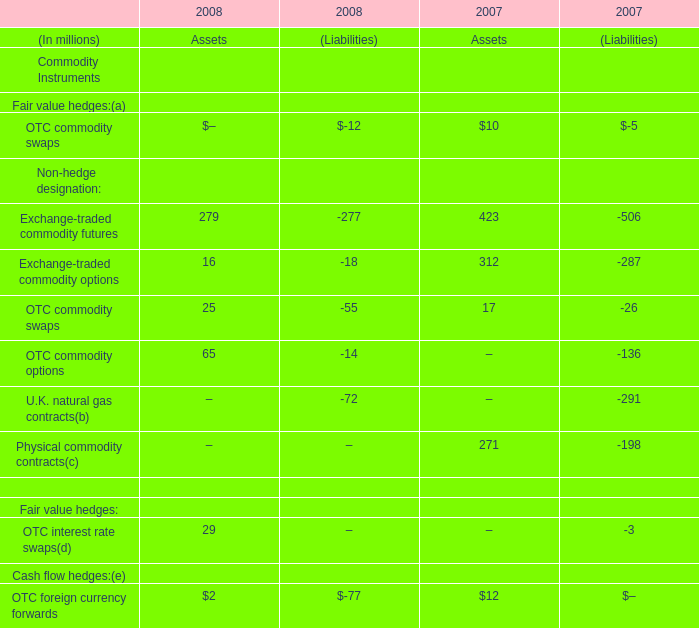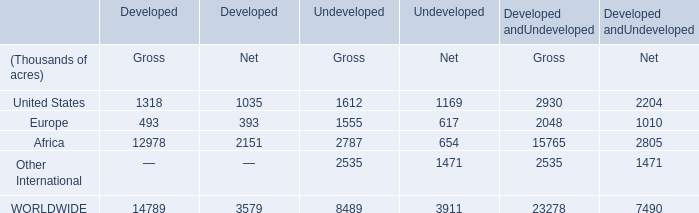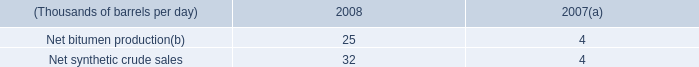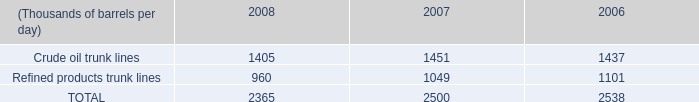what is the highest total amount of Exchange-traded commodity futures? (in million) 
Answer: 423. 